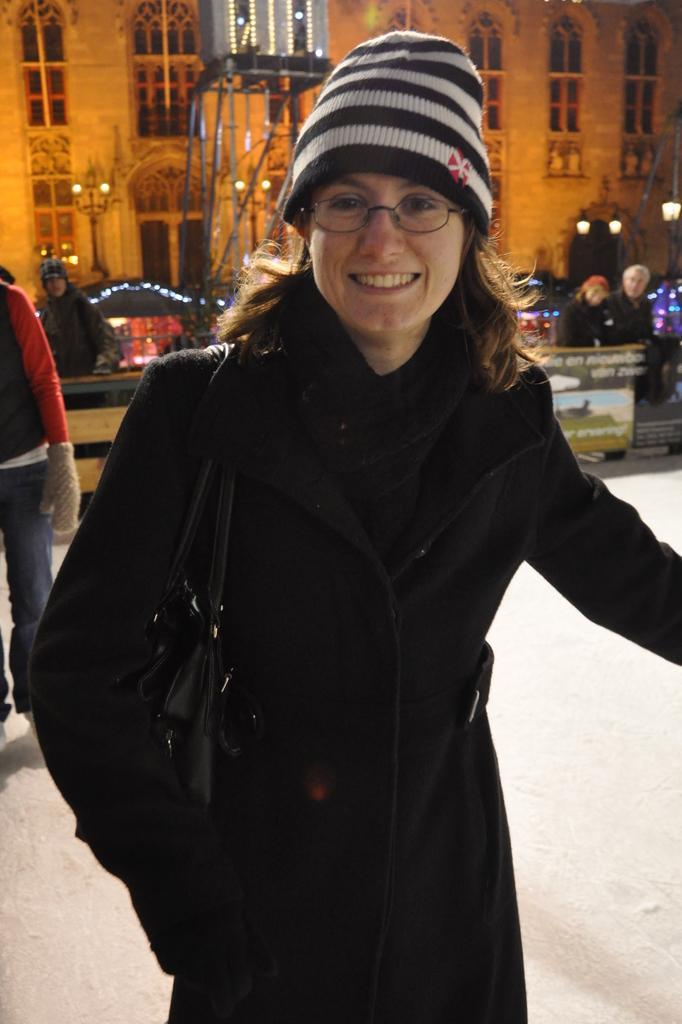Please provide a concise description of this image. In this image we can see a woman smiling in the foreground. The woman is carrying a handbag. Behind the woman we can see banners with text and the persons. In the background, we can see a building and poles with lights. 